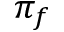Convert formula to latex. <formula><loc_0><loc_0><loc_500><loc_500>\pi _ { f }</formula> 